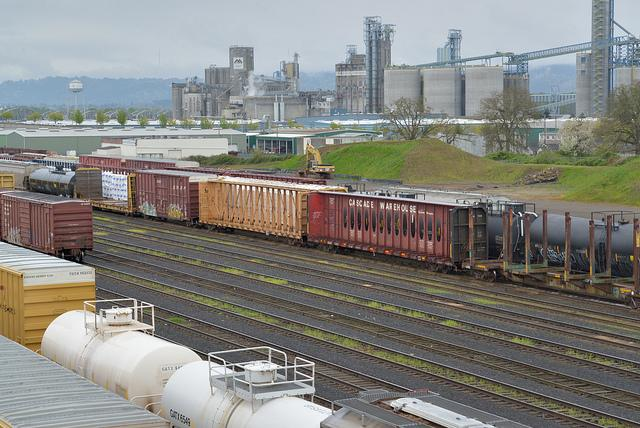What vehicles are here? trains 